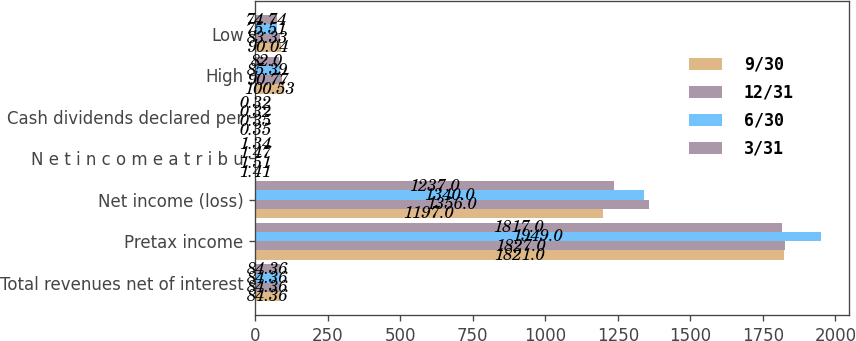Convert chart to OTSL. <chart><loc_0><loc_0><loc_500><loc_500><stacked_bar_chart><ecel><fcel>Total revenues net of interest<fcel>Pretax income<fcel>Net income (loss)<fcel>N e t i n c o m e a t r i b u<fcel>Cash dividends declared per<fcel>High<fcel>Low<nl><fcel>9/30<fcel>84.36<fcel>1821<fcel>1197<fcel>1.41<fcel>0.35<fcel>100.53<fcel>90.04<nl><fcel>12/31<fcel>84.36<fcel>1827<fcel>1356<fcel>1.51<fcel>0.35<fcel>90.77<fcel>83.33<nl><fcel>6/30<fcel>84.36<fcel>1949<fcel>1340<fcel>1.47<fcel>0.32<fcel>85.39<fcel>75.51<nl><fcel>3/31<fcel>84.36<fcel>1817<fcel>1237<fcel>1.34<fcel>0.32<fcel>82<fcel>74.74<nl></chart> 